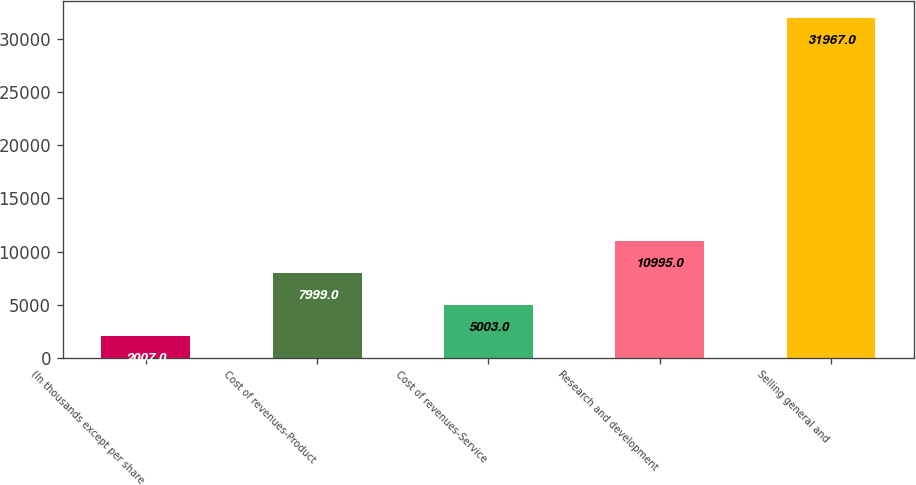Convert chart. <chart><loc_0><loc_0><loc_500><loc_500><bar_chart><fcel>(In thousands except per share<fcel>Cost of revenues-Product<fcel>Cost of revenues-Service<fcel>Research and development<fcel>Selling general and<nl><fcel>2007<fcel>7999<fcel>5003<fcel>10995<fcel>31967<nl></chart> 